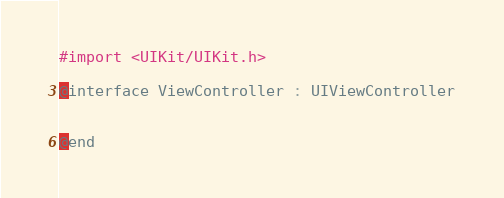Convert code to text. <code><loc_0><loc_0><loc_500><loc_500><_C_>
#import <UIKit/UIKit.h>

@interface ViewController : UIViewController


@end

</code> 